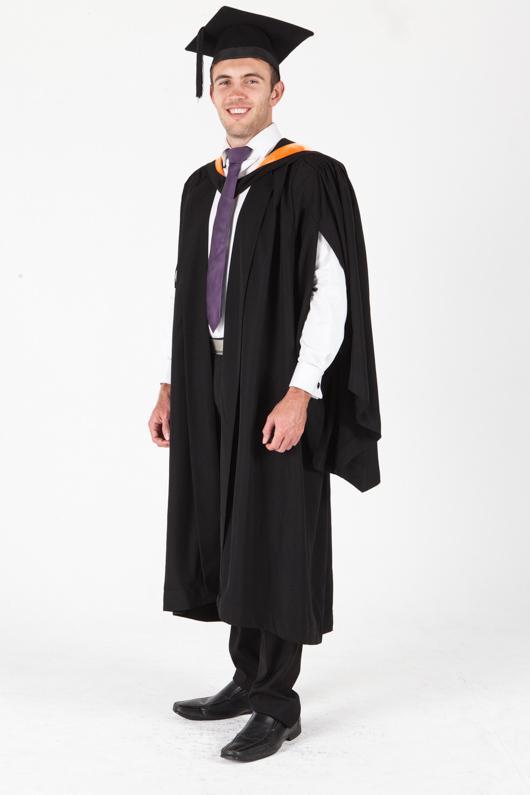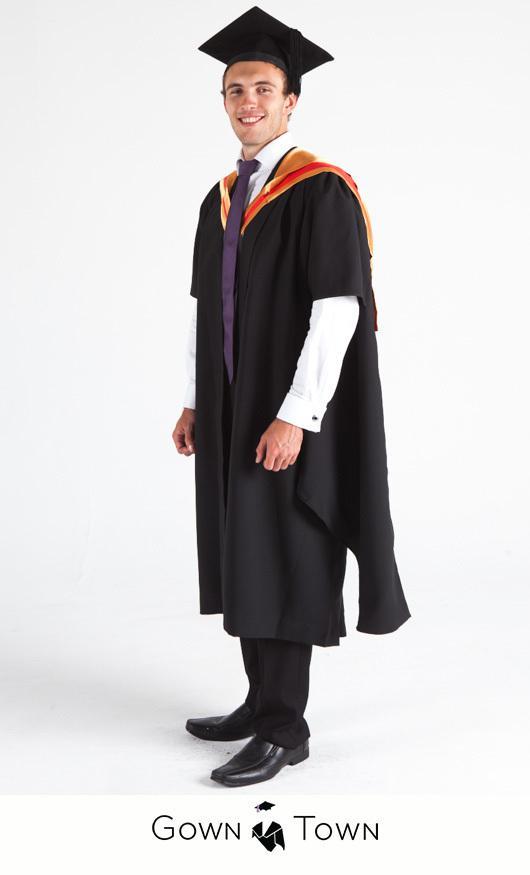The first image is the image on the left, the second image is the image on the right. Given the left and right images, does the statement "In both images a man wearing a black cap and gown and purple tie is standing facing forward with his arms at his sides." hold true? Answer yes or no. No. The first image is the image on the left, the second image is the image on the right. Analyze the images presented: Is the assertion "An image shows a male graduate wearing something yellow around his neck." valid? Answer yes or no. No. 